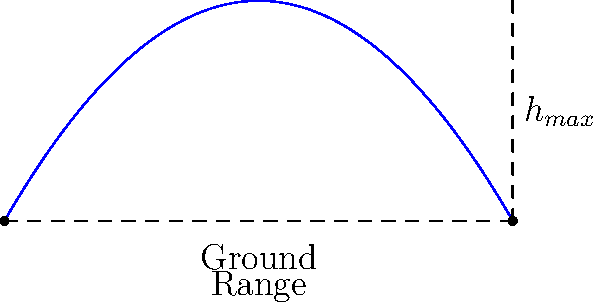As you're practicing for your wedding day basketball shot, you launch a ball with an initial velocity of 15 m/s at an angle of 60° from the horizontal. Assuming no air resistance, what is the maximum height reached by the ball? (Use g = 9.81 m/s²) Let's approach this step-by-step:

1) The maximum height is reached when the vertical velocity becomes zero. We can use the equation:

   $$v_y = v_0 \sin \theta - gt$$

   where $v_y$ is the vertical velocity, $v_0$ is the initial velocity, $\theta$ is the launch angle, $g$ is the acceleration due to gravity, and $t$ is the time.

2) At the highest point, $v_y = 0$, so:

   $$0 = v_0 \sin \theta - gt_{max}$$

3) Solving for $t_{max}$:

   $$t_{max} = \frac{v_0 \sin \theta}{g}$$

4) Substituting the given values:

   $$t_{max} = \frac{15 \sin 60°}{9.81} = \frac{15 * 0.866}{9.81} = 1.32 \text{ s}$$

5) Now we can use the equation for the height:

   $$h = v_0 \sin \theta * t - \frac{1}{2}gt^2$$

6) Substituting $t_{max}$ into this equation:

   $$h_{max} = 15 \sin 60° * 1.32 - \frac{1}{2} * 9.81 * 1.32^2$$

7) Calculating:

   $$h_{max} = 17.15 - 8.57 = 8.58 \text{ m}$$
Answer: 8.58 m 